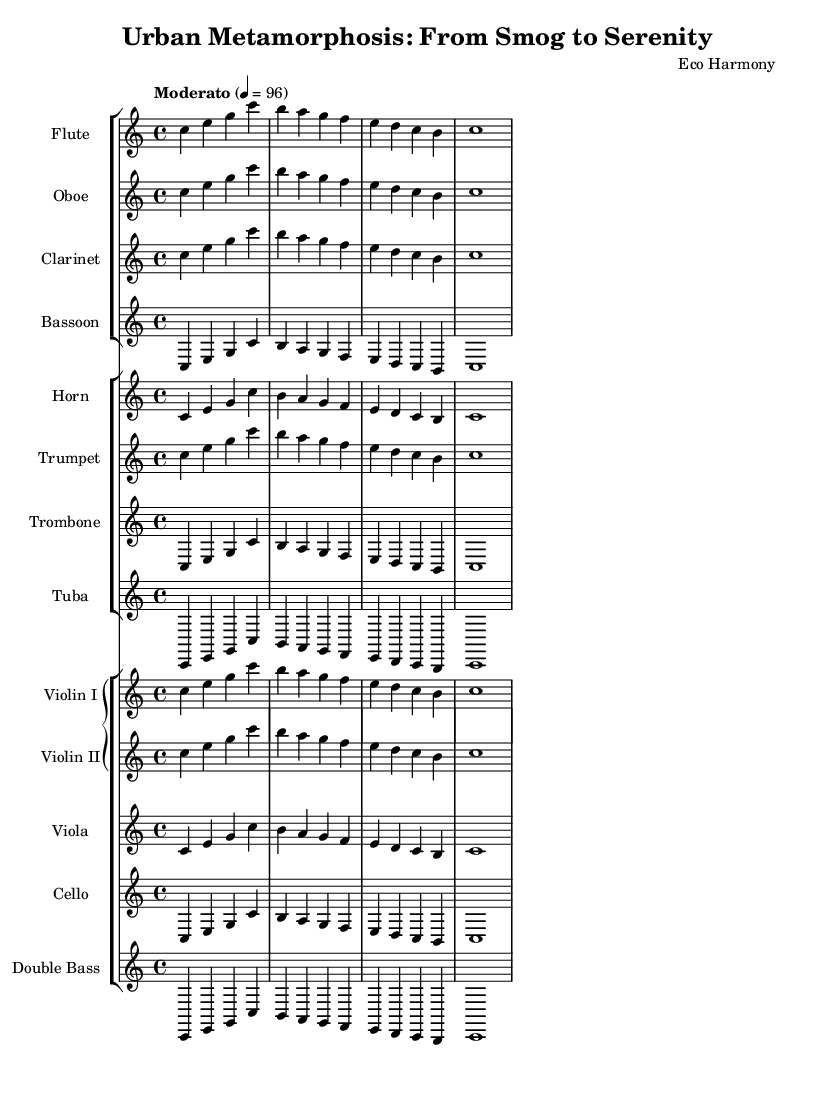What is the title of this piece? The title is found in the header section of the sheet music, where it states "Urban Metamorphosis: From Smog to Serenity."
Answer: Urban Metamorphosis: From Smog to Serenity What is the key signature of this music? The key signature is indicated by the initial note set in the global section, which states the key is C major. C major has no sharps or flats.
Answer: C major What is the time signature of this piece? The time signature is also indicated in the global section, stating it is 4/4, which is common in classical music.
Answer: 4/4 What is the tempo marking of this music? The tempo is provided in the global section, where it specifies "Moderato" with a metronome marking of 4 = 96. It indicates a moderate speed for the performance.
Answer: Moderato How many different instruments are used in the score? To find this, count the number of unique staffs each representing different instruments. There are a total of 12 unique instruments listed.
Answer: 12 Which instrument has the lowest written pitch in the score? Review the instruments listed and identify the ranges. The tuba is recognized as having the lowest written pitch in the score, as it sounds in the bass clef and usually plays in a lower register.
Answer: Tuba Which two instruments are playing the same melody in this score? The flute and oboe are both written with the same notes in the score at the same time, indicating they are performing the same melody together.
Answer: Flute and Oboe 